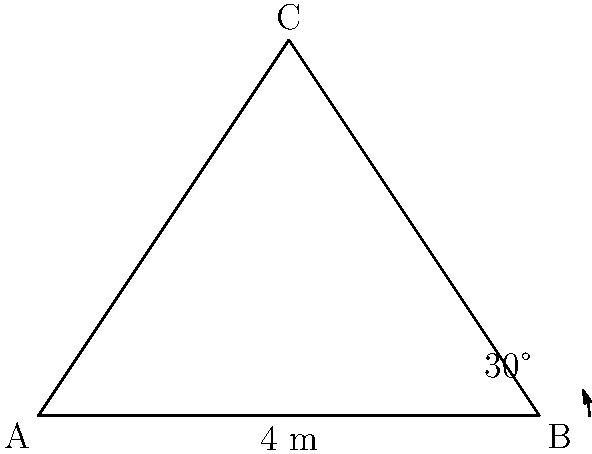In Kozachi Laheri, a traditional house has a triangular roof. The base of the roof is 8 meters wide, and the roof angle is 30°. What is the height of the roof from its base to the peak? Let's solve this step-by-step:

1) The roof forms a right-angled triangle. We know the base (8 meters) and one of the angles (30°).

2) Let's split the base in half. Now we have a right-angled triangle with:
   - The adjacent side (half of the base) = 4 meters
   - The angle = 30°
   - We need to find the opposite side (height of the roof)

3) In a right-angled triangle, $\tan \theta = \frac{\text{opposite}}{\text{adjacent}}$

4) We can write:
   $\tan 30° = \frac{\text{height}}{4}$

5) We know that $\tan 30° = \frac{1}{\sqrt{3}}$

6) Substituting:
   $\frac{1}{\sqrt{3}} = \frac{\text{height}}{4}$

7) Cross multiply:
   $4 = \text{height} \cdot \sqrt{3}$

8) Solve for height:
   $\text{height} = \frac{4}{\sqrt{3}} = \frac{4\sqrt{3}}{3} \approx 2.31$ meters

Therefore, the height of the roof is $\frac{4\sqrt{3}}{3}$ meters or approximately 2.31 meters.
Answer: $\frac{4\sqrt{3}}{3}$ meters 